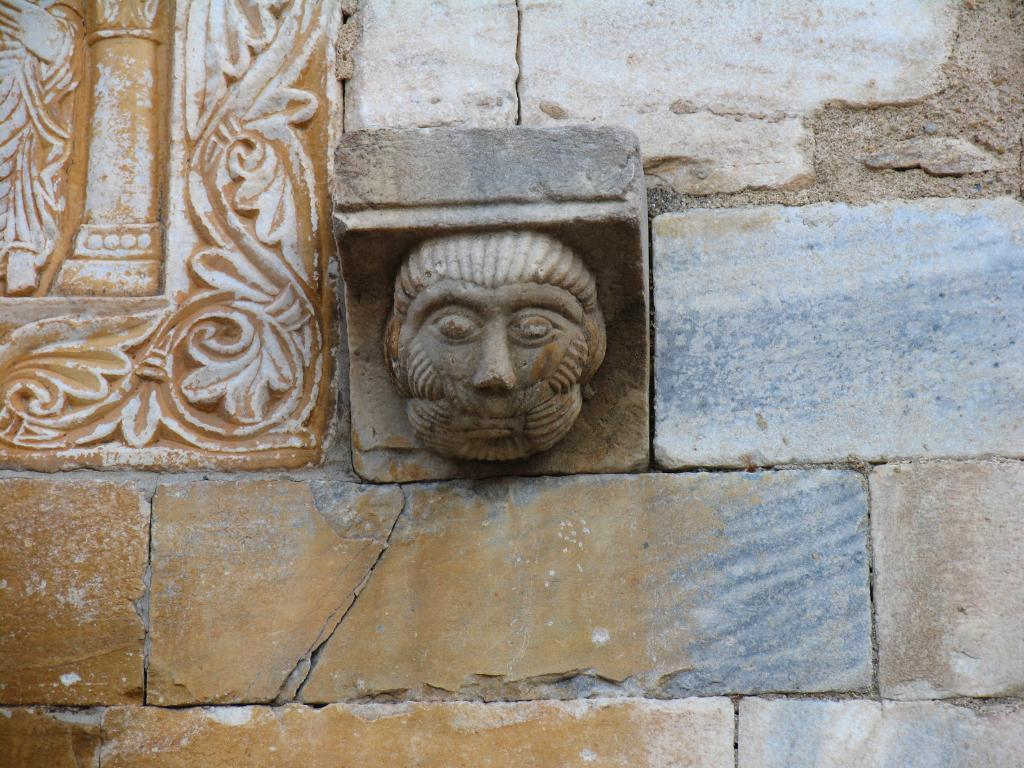What type of structure is visible in the image? There is a brick wall in the image. What is on the brick wall? There is a sculpture on the brick wall. What type of religion is practiced by the person with the prominent chin in the image? There is no person with a prominent chin present in the image, and therefore no religious practice can be observed. What type of plant is growing on the brick wall in the image? There is no plant growing on the brick wall in the image. 